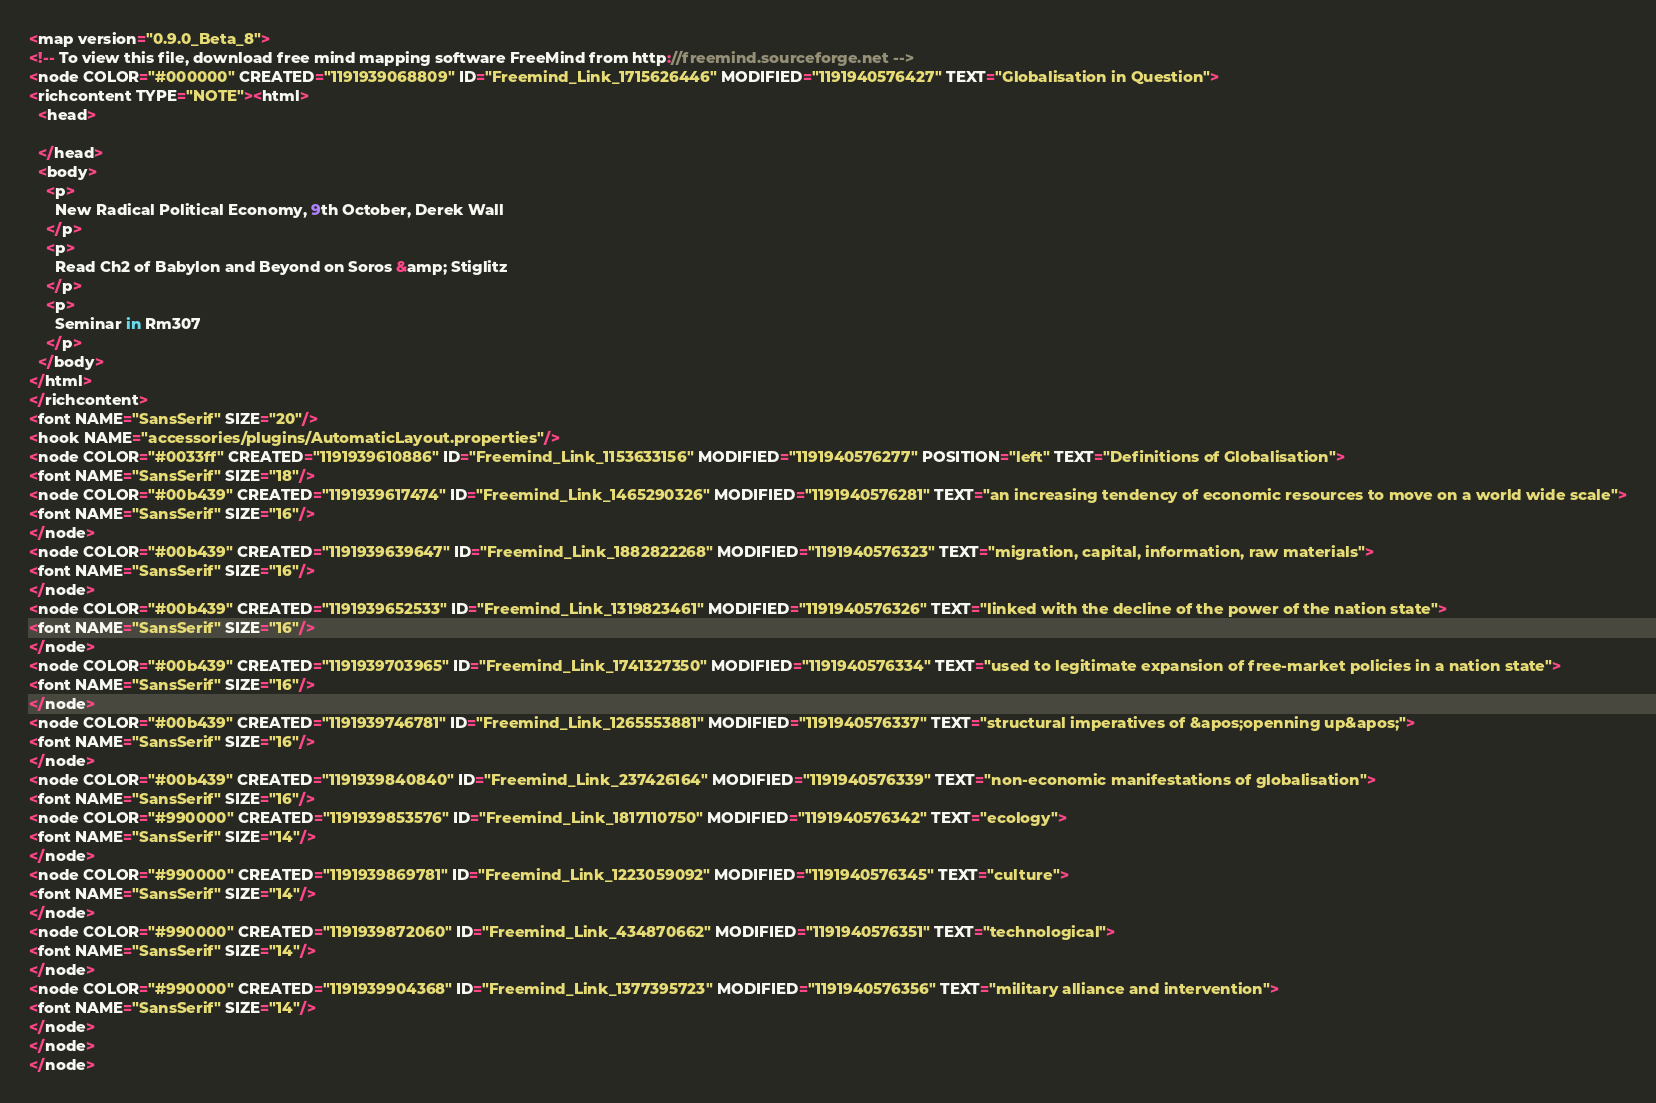Convert code to text. <code><loc_0><loc_0><loc_500><loc_500><_ObjectiveC_><map version="0.9.0_Beta_8">
<!-- To view this file, download free mind mapping software FreeMind from http://freemind.sourceforge.net -->
<node COLOR="#000000" CREATED="1191939068809" ID="Freemind_Link_1715626446" MODIFIED="1191940576427" TEXT="Globalisation in Question">
<richcontent TYPE="NOTE"><html>
  <head>
    
  </head>
  <body>
    <p>
      New Radical Political Economy, 9th October, Derek Wall
    </p>
    <p>
      Read Ch2 of Babylon and Beyond on Soros &amp; Stiglitz
    </p>
    <p>
      Seminar in Rm307
    </p>
  </body>
</html>
</richcontent>
<font NAME="SansSerif" SIZE="20"/>
<hook NAME="accessories/plugins/AutomaticLayout.properties"/>
<node COLOR="#0033ff" CREATED="1191939610886" ID="Freemind_Link_1153633156" MODIFIED="1191940576277" POSITION="left" TEXT="Definitions of Globalisation">
<font NAME="SansSerif" SIZE="18"/>
<node COLOR="#00b439" CREATED="1191939617474" ID="Freemind_Link_1465290326" MODIFIED="1191940576281" TEXT="an increasing tendency of economic resources to move on a world wide scale">
<font NAME="SansSerif" SIZE="16"/>
</node>
<node COLOR="#00b439" CREATED="1191939639647" ID="Freemind_Link_1882822268" MODIFIED="1191940576323" TEXT="migration, capital, information, raw materials">
<font NAME="SansSerif" SIZE="16"/>
</node>
<node COLOR="#00b439" CREATED="1191939652533" ID="Freemind_Link_1319823461" MODIFIED="1191940576326" TEXT="linked with the decline of the power of the nation state">
<font NAME="SansSerif" SIZE="16"/>
</node>
<node COLOR="#00b439" CREATED="1191939703965" ID="Freemind_Link_1741327350" MODIFIED="1191940576334" TEXT="used to legitimate expansion of free-market policies in a nation state">
<font NAME="SansSerif" SIZE="16"/>
</node>
<node COLOR="#00b439" CREATED="1191939746781" ID="Freemind_Link_1265553881" MODIFIED="1191940576337" TEXT="structural imperatives of &apos;openning up&apos;">
<font NAME="SansSerif" SIZE="16"/>
</node>
<node COLOR="#00b439" CREATED="1191939840840" ID="Freemind_Link_237426164" MODIFIED="1191940576339" TEXT="non-economic manifestations of globalisation">
<font NAME="SansSerif" SIZE="16"/>
<node COLOR="#990000" CREATED="1191939853576" ID="Freemind_Link_1817110750" MODIFIED="1191940576342" TEXT="ecology">
<font NAME="SansSerif" SIZE="14"/>
</node>
<node COLOR="#990000" CREATED="1191939869781" ID="Freemind_Link_1223059092" MODIFIED="1191940576345" TEXT="culture">
<font NAME="SansSerif" SIZE="14"/>
</node>
<node COLOR="#990000" CREATED="1191939872060" ID="Freemind_Link_434870662" MODIFIED="1191940576351" TEXT="technological">
<font NAME="SansSerif" SIZE="14"/>
</node>
<node COLOR="#990000" CREATED="1191939904368" ID="Freemind_Link_1377395723" MODIFIED="1191940576356" TEXT="military alliance and intervention">
<font NAME="SansSerif" SIZE="14"/>
</node>
</node>
</node></code> 